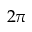<formula> <loc_0><loc_0><loc_500><loc_500>2 \pi</formula> 